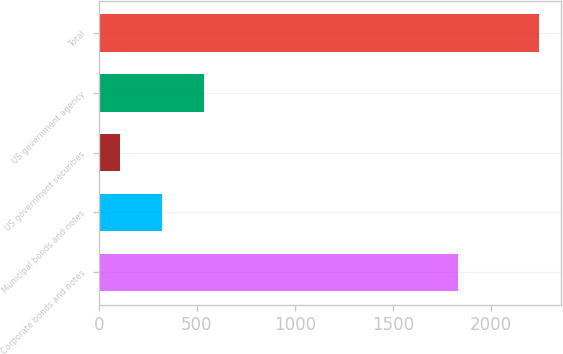Convert chart to OTSL. <chart><loc_0><loc_0><loc_500><loc_500><bar_chart><fcel>Corporate bonds and notes<fcel>Municipal bonds and notes<fcel>US government securities<fcel>US government agency<fcel>Total<nl><fcel>1835<fcel>322.6<fcel>109<fcel>536.2<fcel>2245<nl></chart> 